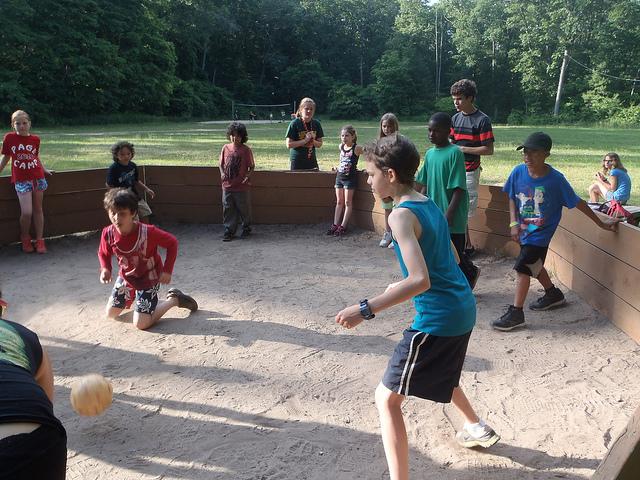Are there more boys or girls in the picture?
Quick response, please. Boys. Is there grass in the image?
Quick response, please. Yes. What the shape of the half wall?
Write a very short answer. Octagon. Is there a ramp at the park?
Concise answer only. No. How many women are sitting on the cement?
Be succinct. 0. Is the child wearing a protective helmet?
Quick response, please. No. How many boys are pictured?
Keep it brief. 7. What surface are the children playing on?
Short answer required. Sand. 